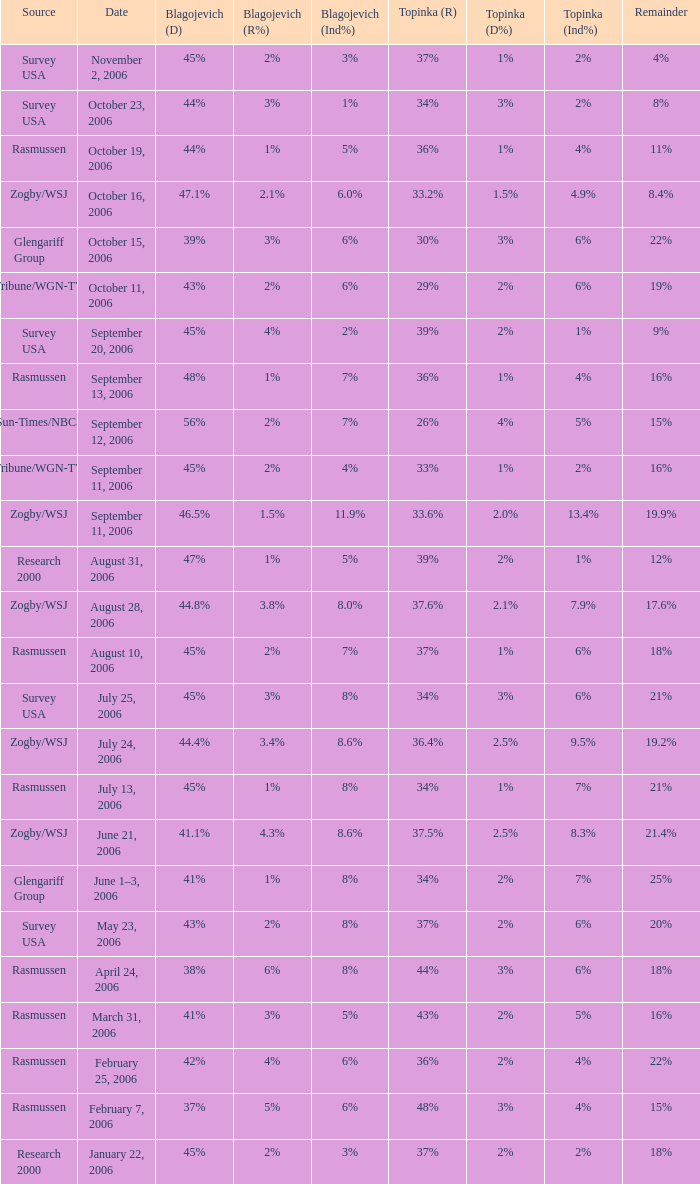Which Blagojevich (D) happened on october 16, 2006? 47.1%. 